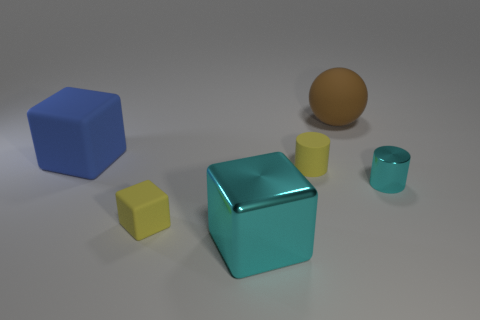What number of big objects are either yellow rubber balls or yellow rubber blocks?
Provide a short and direct response. 0. There is a tiny object that is to the left of the tiny yellow rubber cylinder in front of the large matte block; are there any big blue rubber blocks that are on the right side of it?
Make the answer very short. No. Is there a red sphere of the same size as the blue matte object?
Provide a succinct answer. No. There is a blue object that is the same size as the ball; what is its material?
Give a very brief answer. Rubber. There is a blue object; is it the same size as the yellow cube that is in front of the big brown matte ball?
Make the answer very short. No. What number of metallic things are either cyan objects or large green objects?
Make the answer very short. 2. How many brown objects have the same shape as the small cyan object?
Offer a very short reply. 0. There is a tiny cylinder that is the same color as the large shiny cube; what is it made of?
Keep it short and to the point. Metal. Does the cyan object that is left of the brown rubber sphere have the same size as the object that is behind the blue rubber cube?
Ensure brevity in your answer.  Yes. What is the shape of the rubber object that is left of the small rubber cube?
Provide a succinct answer. Cube. 